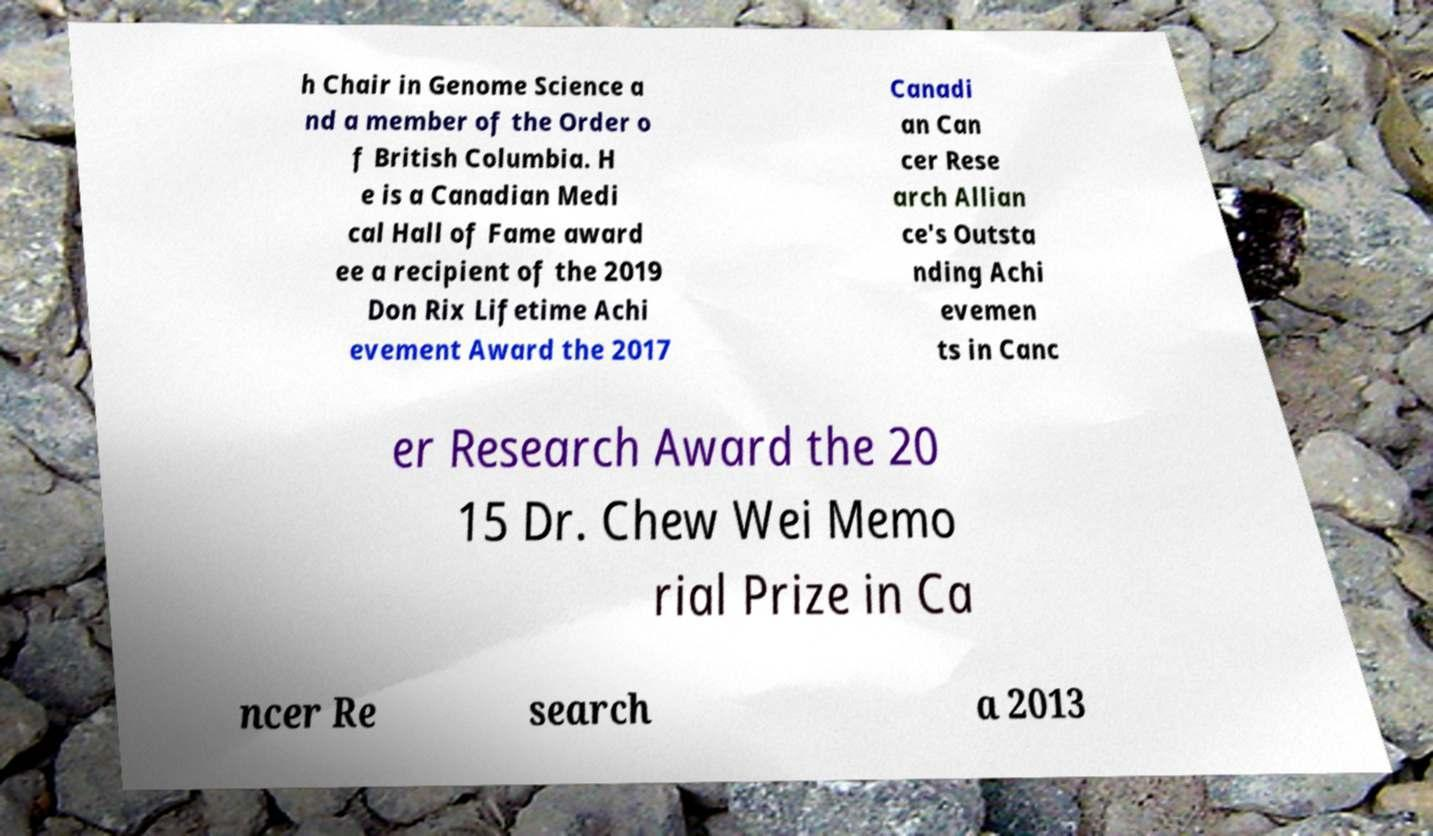I need the written content from this picture converted into text. Can you do that? h Chair in Genome Science a nd a member of the Order o f British Columbia. H e is a Canadian Medi cal Hall of Fame award ee a recipient of the 2019 Don Rix Lifetime Achi evement Award the 2017 Canadi an Can cer Rese arch Allian ce's Outsta nding Achi evemen ts in Canc er Research Award the 20 15 Dr. Chew Wei Memo rial Prize in Ca ncer Re search a 2013 